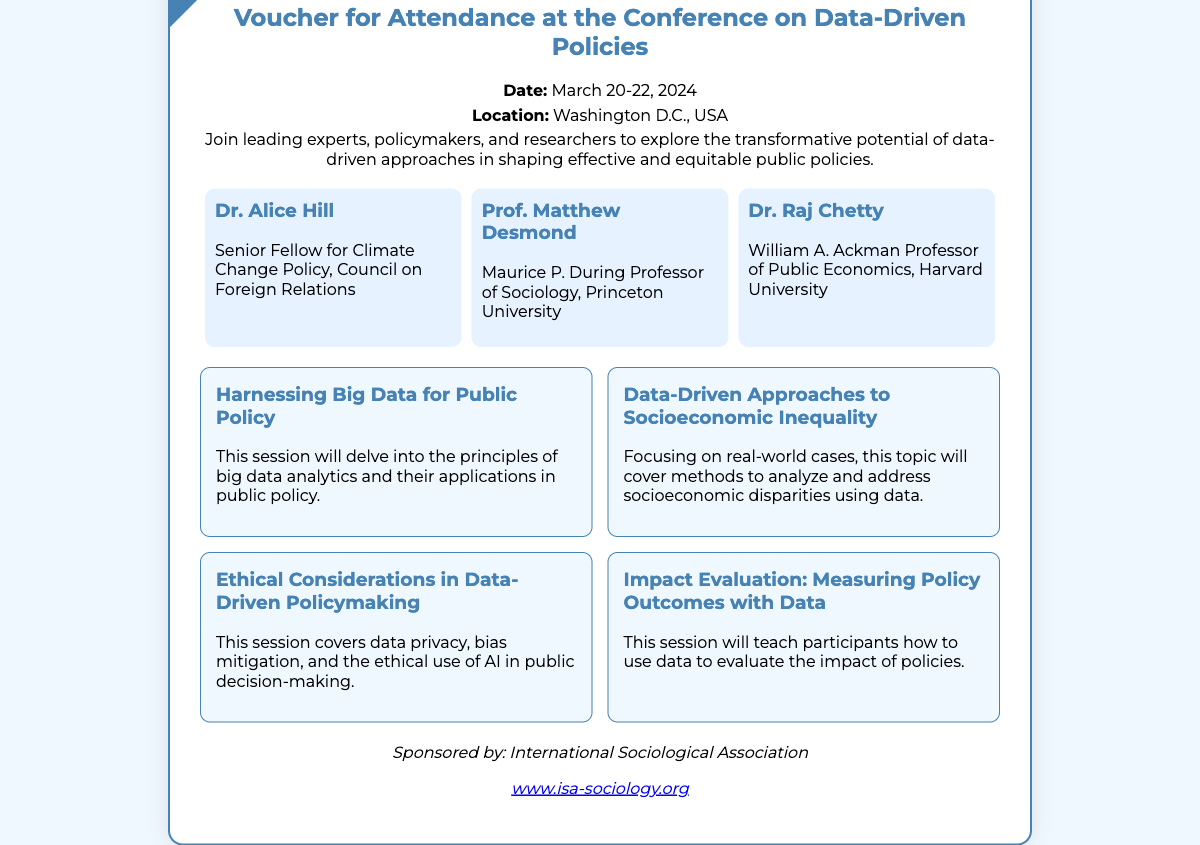What are the dates of the conference? The dates of the conference can be found in the event details section, which states that the conference will take place from March 20-22, 2024.
Answer: March 20-22, 2024 Where is the conference location? The conference location is specified in the event details, which mentions Washington D.C., USA.
Answer: Washington D.C., USA Who is Dr. Raj Chetty? Dr. Raj Chetty's name and title are found in the speakers section, where he is listed as the William A. Ackman Professor of Public Economics at Harvard University.
Answer: William A. Ackman Professor of Public Economics, Harvard University What is one topic covered in the conference? The topics covered in the conference are listed in the topics section, one of which is "Harnessing Big Data for Public Policy."
Answer: Harnessing Big Data for Public Policy Who sponsors the conference? The sponsorship information can be found at the bottom of the voucher, indicating that the conference is sponsored by the International Sociological Association.
Answer: International Sociological Association What is the focus of the session on socioeconomic inequality? The focus of this session is described to cover methods to analyze and address socioeconomic disparities using data, as stated in the topics section.
Answer: Analyze and address socioeconomic disparities using data How many speakers are mentioned? The number of speakers can be determined by counting the entries in the speakers section, which lists three individuals.
Answer: 3 What is the purpose of the conference? The purpose of the conference is described in the event details and mentions exploring the transformative potential of data-driven approaches in shaping effective and equitable public policies.
Answer: Explore the transformative potential of data-driven approaches 